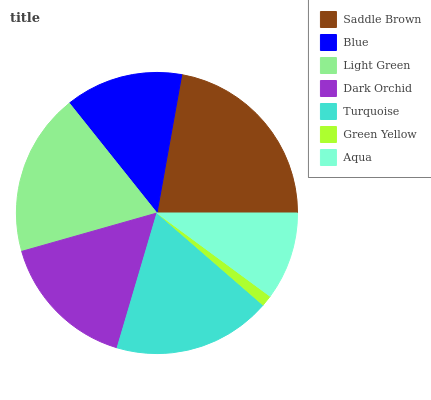Is Green Yellow the minimum?
Answer yes or no. Yes. Is Saddle Brown the maximum?
Answer yes or no. Yes. Is Blue the minimum?
Answer yes or no. No. Is Blue the maximum?
Answer yes or no. No. Is Saddle Brown greater than Blue?
Answer yes or no. Yes. Is Blue less than Saddle Brown?
Answer yes or no. Yes. Is Blue greater than Saddle Brown?
Answer yes or no. No. Is Saddle Brown less than Blue?
Answer yes or no. No. Is Dark Orchid the high median?
Answer yes or no. Yes. Is Dark Orchid the low median?
Answer yes or no. Yes. Is Blue the high median?
Answer yes or no. No. Is Turquoise the low median?
Answer yes or no. No. 